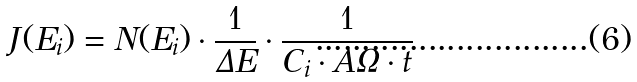<formula> <loc_0><loc_0><loc_500><loc_500>J ( E _ { i } ) = N ( E _ { i } ) \cdot \frac { 1 } { \Delta E } \cdot \frac { 1 } { C _ { i } \cdot A \Omega \cdot t }</formula> 